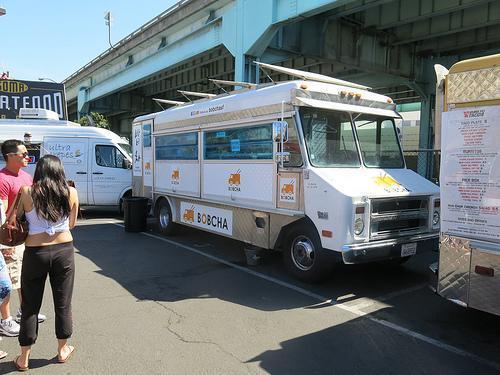How many people are wearing pink shirt?
Give a very brief answer. 1. 